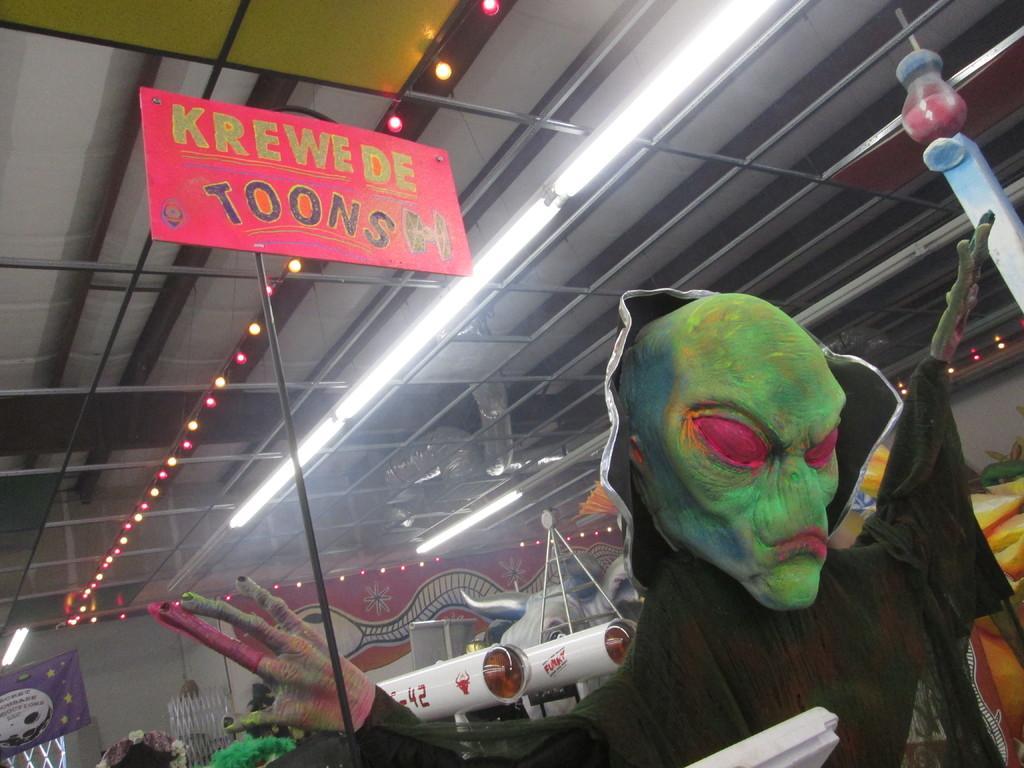Describe this image in one or two sentences. The picture is taken in a room. In the foreground of the picture there is a duplicate of alien. At the top there are lights, frames to the ceiling. In the center of the picture there are many objects. 